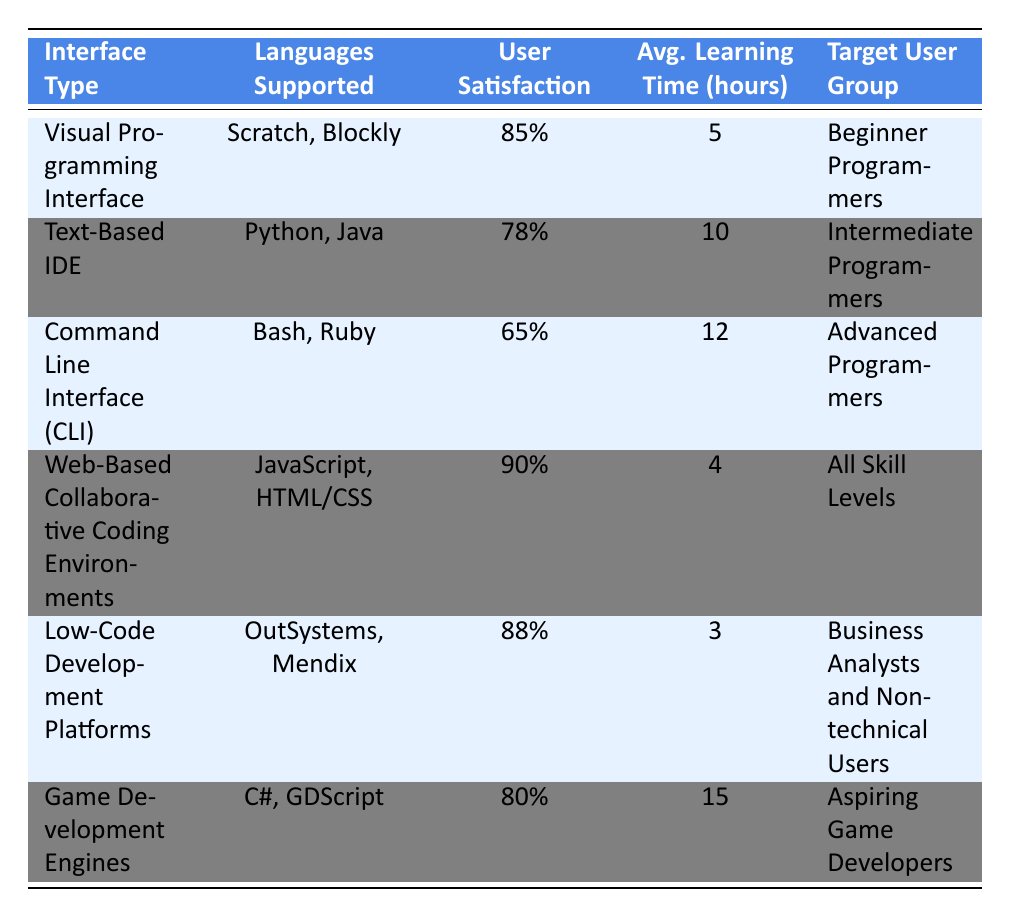What is the user satisfaction rating for the Visual Programming Interface? The table lists the user satisfaction rating for the Visual Programming Interface as 85%.
Answer: 85% Which interface has the highest user satisfaction rating? By comparing the user satisfaction ratings in the table, the Web-Based Collaborative Coding Environments is the highest at 90%.
Answer: 90% What is the average learning time for the Low-Code Development Platforms? According to the table, the average learning time for Low-Code Development Platforms is 3 hours.
Answer: 3 hours Is the user satisfaction rating for the Command Line Interface higher than 70%? The table shows that the Command Line Interface has a user satisfaction rating of 65%, which is lower than 70%.
Answer: No What is the average user satisfaction rating of all interfaces? To find the average user satisfaction rating, sum the ratings: (85 + 78 + 65 + 90 + 88 + 80) = 486. Then divide by the number of interfaces, which is 6. So, 486/6 = 81.
Answer: 81 How many interfaces have a user satisfaction rating above 80%? The interfaces with ratings above 80% are the Visual Programming Interface (85%), Web-Based Collaborative Coding Environments (90%), and Low-Code Development Platforms (88%). This counts to 3 interfaces.
Answer: 3 Which user group has the lowest average learning time? The average learning times are 5 hours for Beginners, 10 hours for Intermediates, 12 for Advanced, 4 for All Skill Levels, 3 for Business Analysts, and 15 for Aspiring Game Developers. The lowest is 3 hours for Business Analysts.
Answer: Business Analysts Is it true that Game Development Engines support only one programming language? The table lists two languages, C# and GDScript, supported by Game Development Engines; therefore, it is false that they support only one.
Answer: No What interface has the longest average learning time? Examining the average learning times, the Game Development Engines have the longest at 15 hours.
Answer: 15 hours 